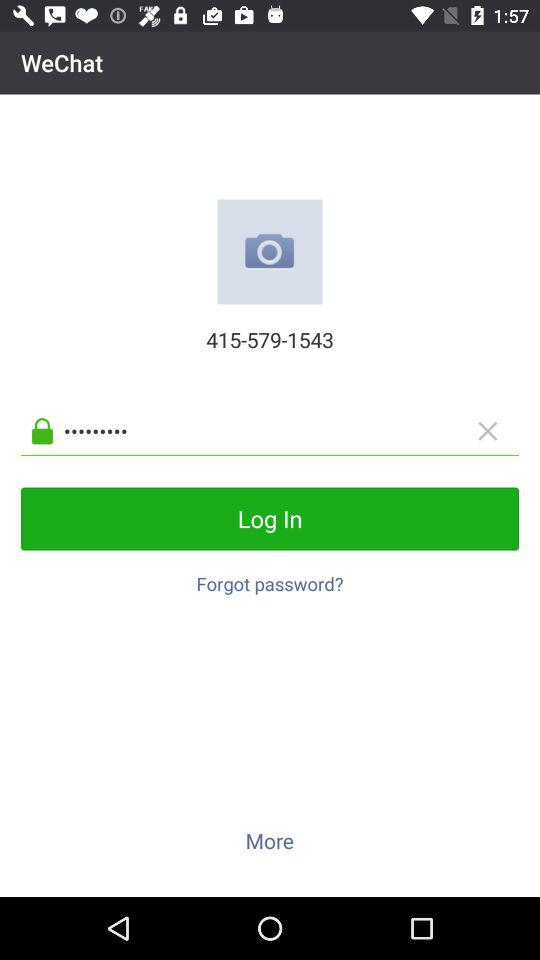What is the number displayed on the screen? The number is 415-579-1543. 